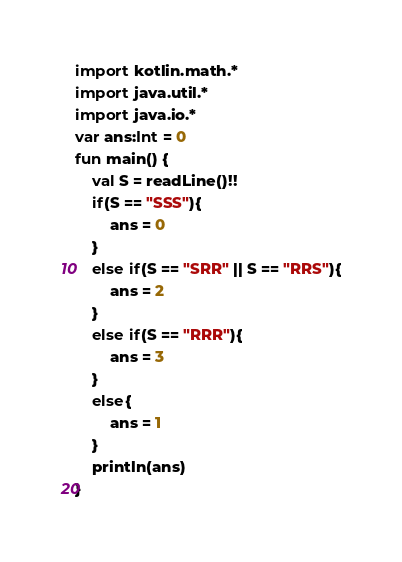<code> <loc_0><loc_0><loc_500><loc_500><_Kotlin_>import kotlin.math.*
import java.util.*
import java.io.*
var ans:Int = 0
fun main() {
    val S = readLine()!!
    if(S == "SSS"){
        ans = 0
    }
    else if(S == "SRR" || S == "RRS"){
        ans = 2
    }
    else if(S == "RRR"){
        ans = 3
    }
    else{
        ans = 1
    }
    println(ans)
}</code> 